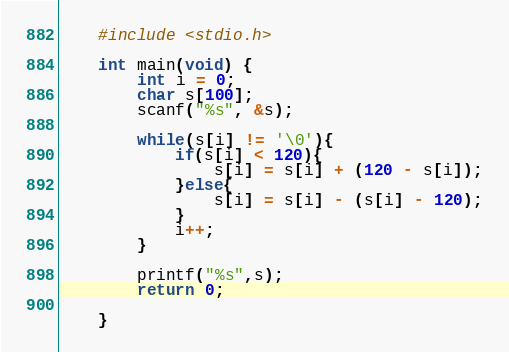Convert code to text. <code><loc_0><loc_0><loc_500><loc_500><_C_>    #include <stdio.h>
     
    int main(void) {
        int i = 0;
        char s[100];
        scanf("%s", &s);

        while(s[i] != '\0'){
            if(s[i] < 120){
                s[i] = s[i] + (120 - s[i]);
            }else{
                s[i] = s[i] - (s[i] - 120);
            }
            i++;
        } 

        printf("%s",s);
        return 0;
     
    }</code> 